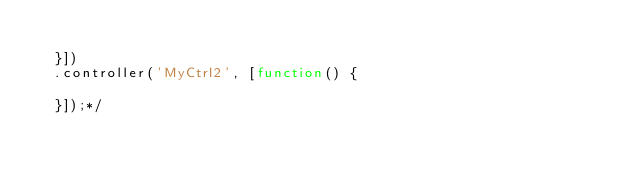<code> <loc_0><loc_0><loc_500><loc_500><_JavaScript_>
  }])
  .controller('MyCtrl2', [function() {

  }]);*/</code> 